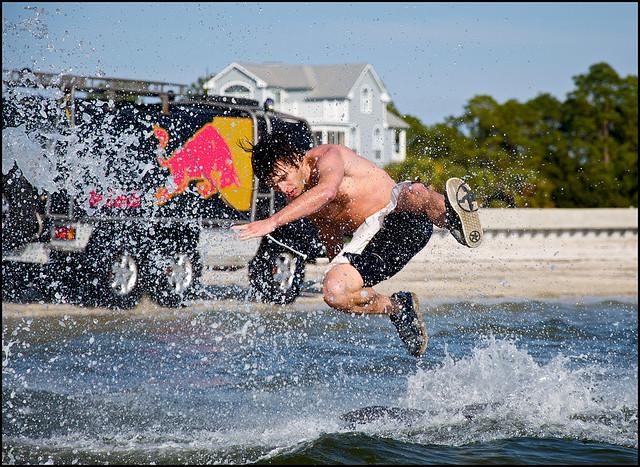What kind of shoes is this person wearing?
Give a very brief answer. Sneakers. Is the person falling?
Quick response, please. Yes. What type of building is in the background?
Short answer required. House. 